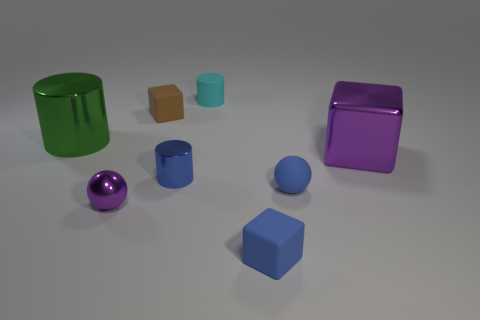There is a cyan matte object; is its size the same as the rubber cube that is in front of the blue metallic object?
Provide a short and direct response. Yes. Is the number of small purple metal things that are to the left of the small purple sphere less than the number of tiny red rubber cubes?
Give a very brief answer. No. What number of small cylinders are the same color as the small matte ball?
Offer a very short reply. 1. Is the number of gray rubber things less than the number of tiny blue blocks?
Ensure brevity in your answer.  Yes. Does the tiny blue block have the same material as the green object?
Give a very brief answer. No. What number of other objects are the same size as the blue block?
Make the answer very short. 5. What color is the sphere that is left of the tiny matte block that is behind the tiny blue shiny object?
Make the answer very short. Purple. What number of other objects are there of the same shape as the tiny brown rubber thing?
Provide a succinct answer. 2. Are there any yellow spheres made of the same material as the blue ball?
Give a very brief answer. No. What material is the purple ball that is the same size as the blue cube?
Your answer should be compact. Metal. 